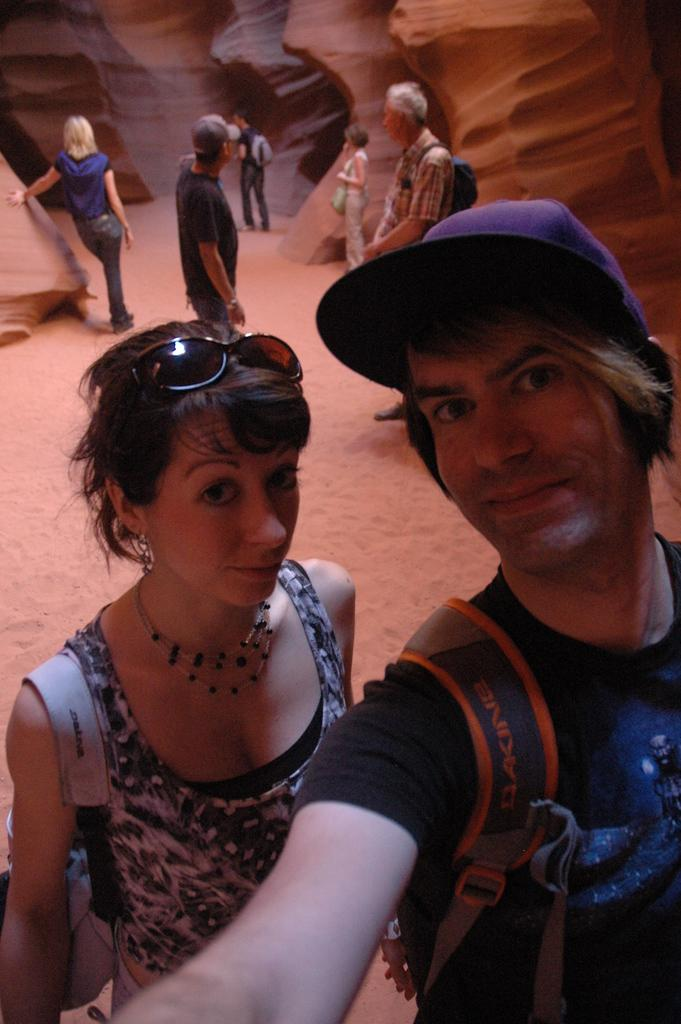How many people are in the foreground of the image? There are two people in the foreground of the image. What are the two people in the foreground doing? The two people in the foreground appear to be taking a selfie. Can you describe the background of the image? There are other people visible behind the two people in the foreground. What type of orange is being used as a prop in the selfie? There is no orange present in the image; the two people are taking a selfie without any visible props. 